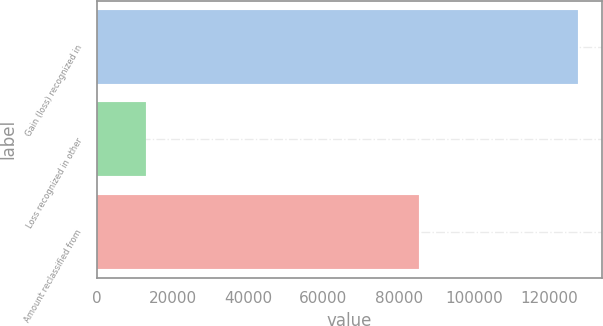<chart> <loc_0><loc_0><loc_500><loc_500><bar_chart><fcel>Gain (loss) recognized in<fcel>Loss recognized in other<fcel>Amount reclassified from<nl><fcel>127470<fcel>12850<fcel>85448<nl></chart> 